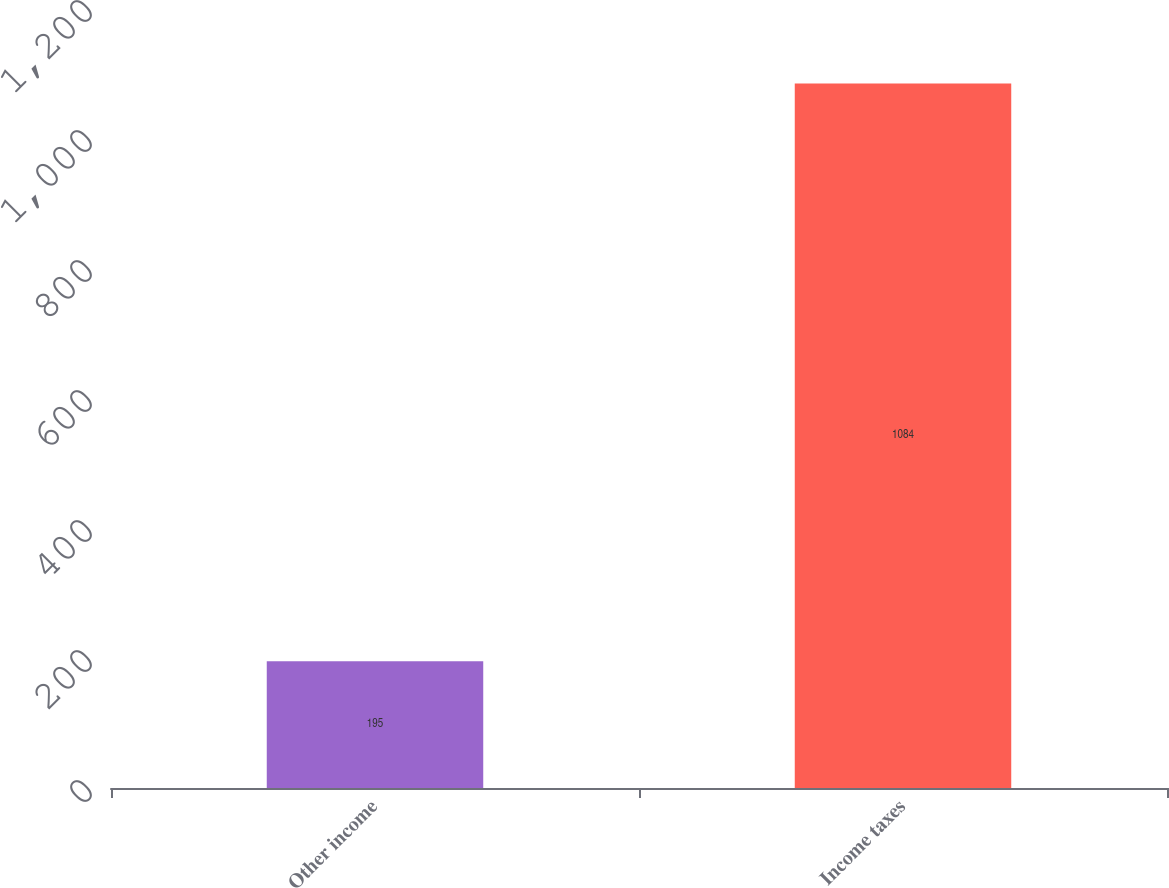Convert chart. <chart><loc_0><loc_0><loc_500><loc_500><bar_chart><fcel>Other income<fcel>Income taxes<nl><fcel>195<fcel>1084<nl></chart> 